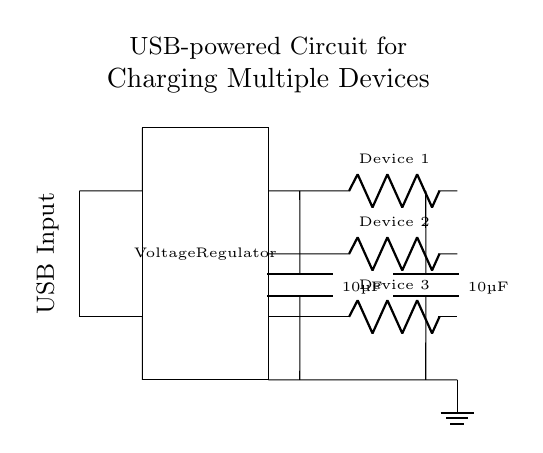What is the input type of this circuit? The input type is a USB input, which is commonly used to power devices; it's indicated by the label in the diagram.
Answer: USB Input How many devices can be charged simultaneously? There are three output lines leading to three labeled devices, which means the circuit can charge three devices at the same time.
Answer: Three What component stabilizes the voltage? The voltage regulator is the component responsible for stabilizing the voltage in the circuit, ensuring that the output remains consistent despite variations in the input.
Answer: Voltage Regulator What is the capacitance of each capacitor? Each capacitor is labeled as 10 microfarads, indicating their value for filtering and stability purposes in the circuit.
Answer: 10 microfarads Which part connects to ground? The ground connection is indicated by the ground symbol at the lowest point of the circuit, which connects to the output paths for all devices.
Answer: Output lines What happens if the voltage regulator fails? If the voltage regulator fails, the circuit may deliver an unstable voltage to the devices, potentially damaging them due to overvoltage or undervoltage.
Answer: Unstable voltage 